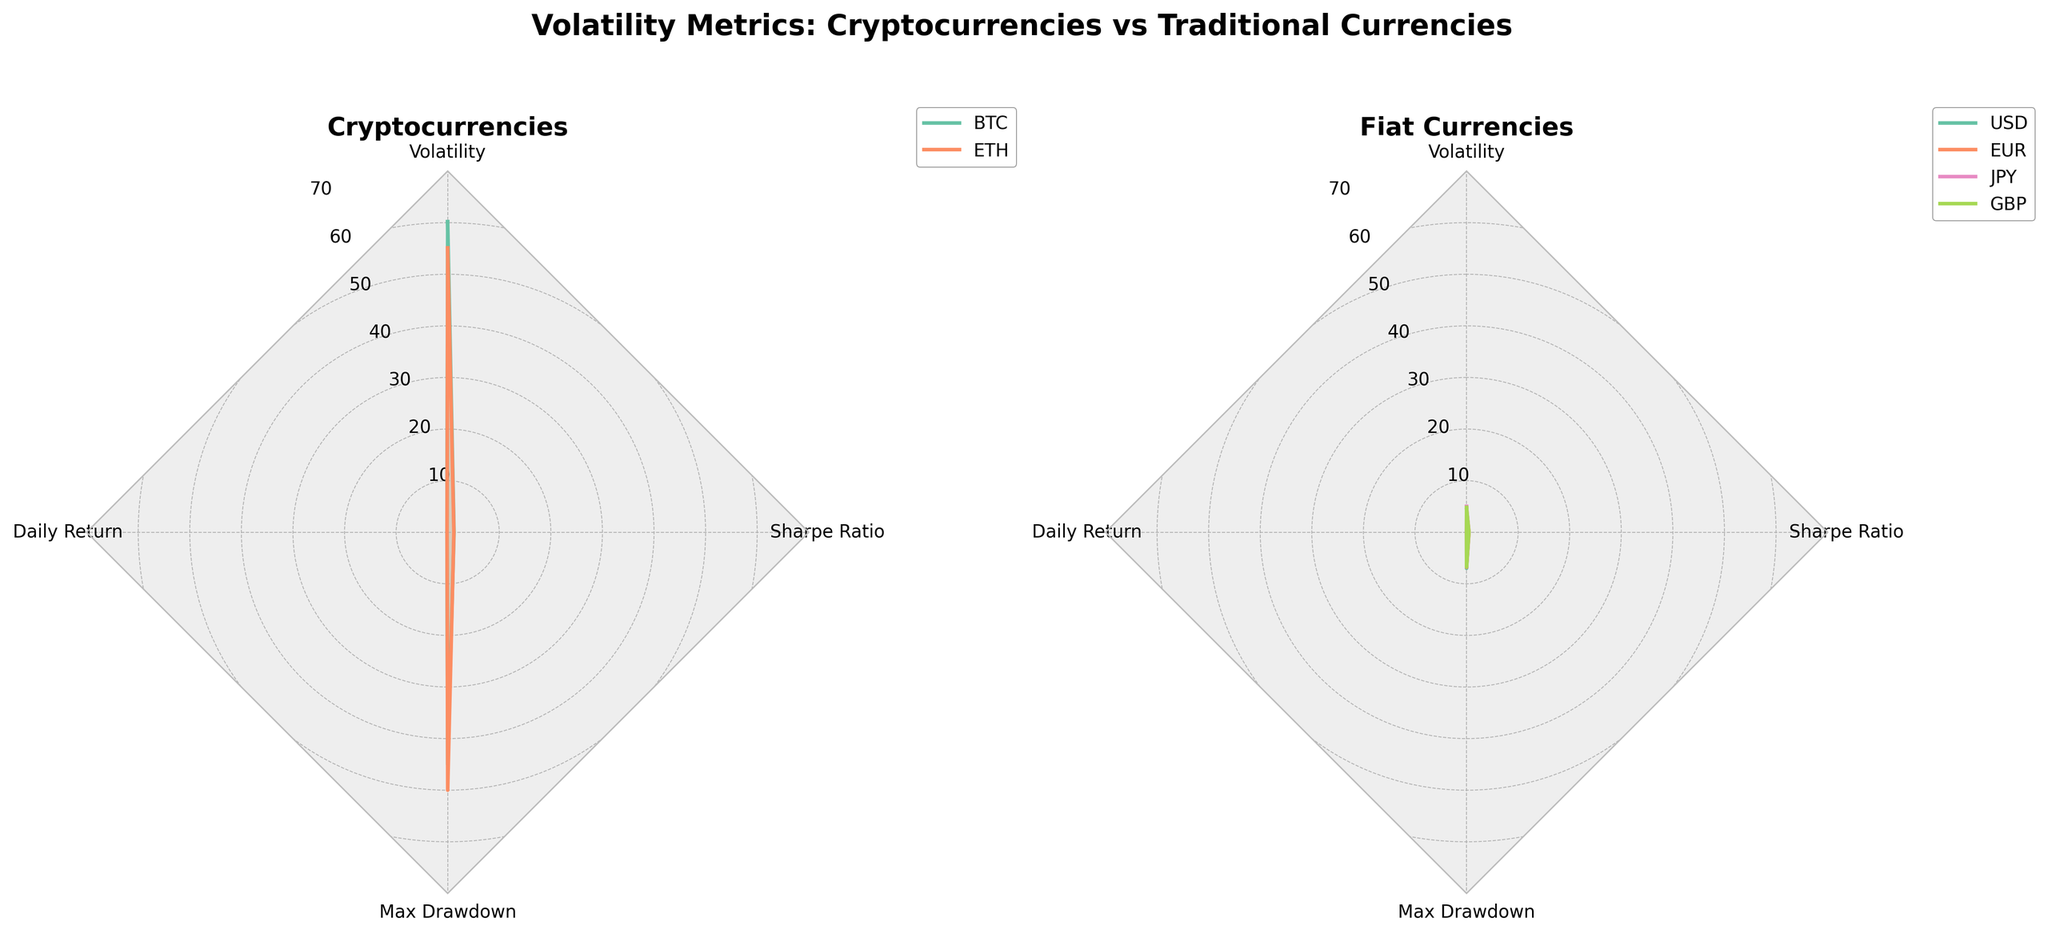What are the currencies shown on the left subplot? The left subplot shows data on two cryptocurrencies. By referring to the radar chart's legend or labels on the left subplot, we can identify the currencies.
Answer: BTC and ETH Which metric shows the highest value for BTC? To determine this, identify and compare the values of BTC across all metrics on the radar chart. The metric nearest the outermost part of the radar chart has the highest value.
Answer: Volatility Compare the daily return of BTC and ETH. Which cryptocurrency has a higher daily return? Using the radar chart, locate the daily return values for both BTC and ETH and compare them. BTC's value is slightly higher.
Answer: BTC What is the overall range of volatility values for the fiat currencies? To find the range, identify the minimum and maximum values of volatility for USD, EUR, JPY, and GBP on the right subplot. The lowest volatility is 4.3 (USD), and the highest is 5.0 (JPY).
Answer: 4.3 to 5.0 Which metric shows the smallest difference between BTC and ETH? Review all metrics for BTC and ETH, then compute the difference for each pair. The smallest difference occurs in the Sharpe Ratio [abs(1.23 - 1.20) = 0.03].
Answer: Sharpe Ratio Among the displayed currencies, which has the lowest Sharpe Ratio? Use the radar chart to find the Sharpe Ratios for all currencies. The one with the shortest radial length in the Sharpe Ratio axis indicates the lowest value, which is JPY (0.42).
Answer: JPY How does the volatility of cryptocurrencies compare to fiat currencies? By visually comparing the extent of the volatility axes in both subplots, it’s apparent that cryptocurrency volatilities (60.2 and 55.1) are far higher than those of fiat currencies (ranging from 4.3 to 5.0).
Answer: Cryptocurrencies have much higher volatility Which currency shows the most significant max drawdown? Locate the axis for max drawdown and compare the values of all currencies from both subplots. ETH has the highest drawdown with 50.0.
Answer: ETH What is the maximum daily return for fiat currencies? Identify the daily return value for each fiat currency (USD, EUR, JPY, GBP) on the radar chart. All fiat currencies have a daily return of 0.01.
Answer: 0.01 How do the Sharpe Ratios of BTC and ETH compare to USD? Examine the Sharpe Ratio values for BTC, ETH, and USD from both subplots. BTC and ETH have much higher Sharpe ratios (1.23 and 1.20) compared to USD (0.45).
Answer: BTC and ETH have much higher Sharpe Ratios compared to USD 